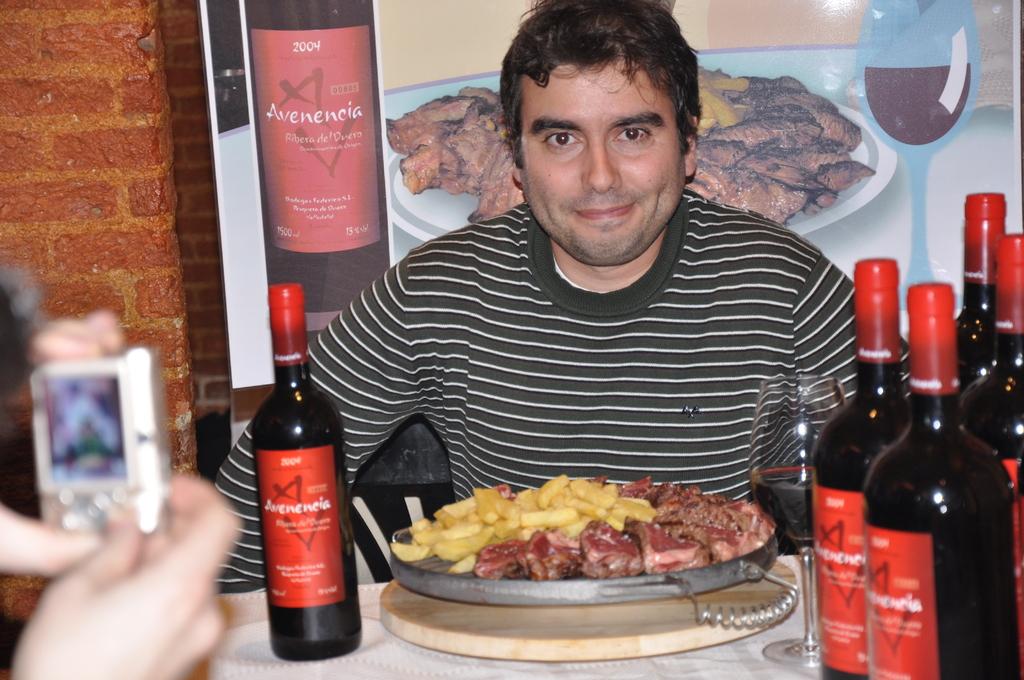What year was this wine produced?
Your answer should be very brief. 2004. What brand is this wine?
Provide a succinct answer. Avenencia. 